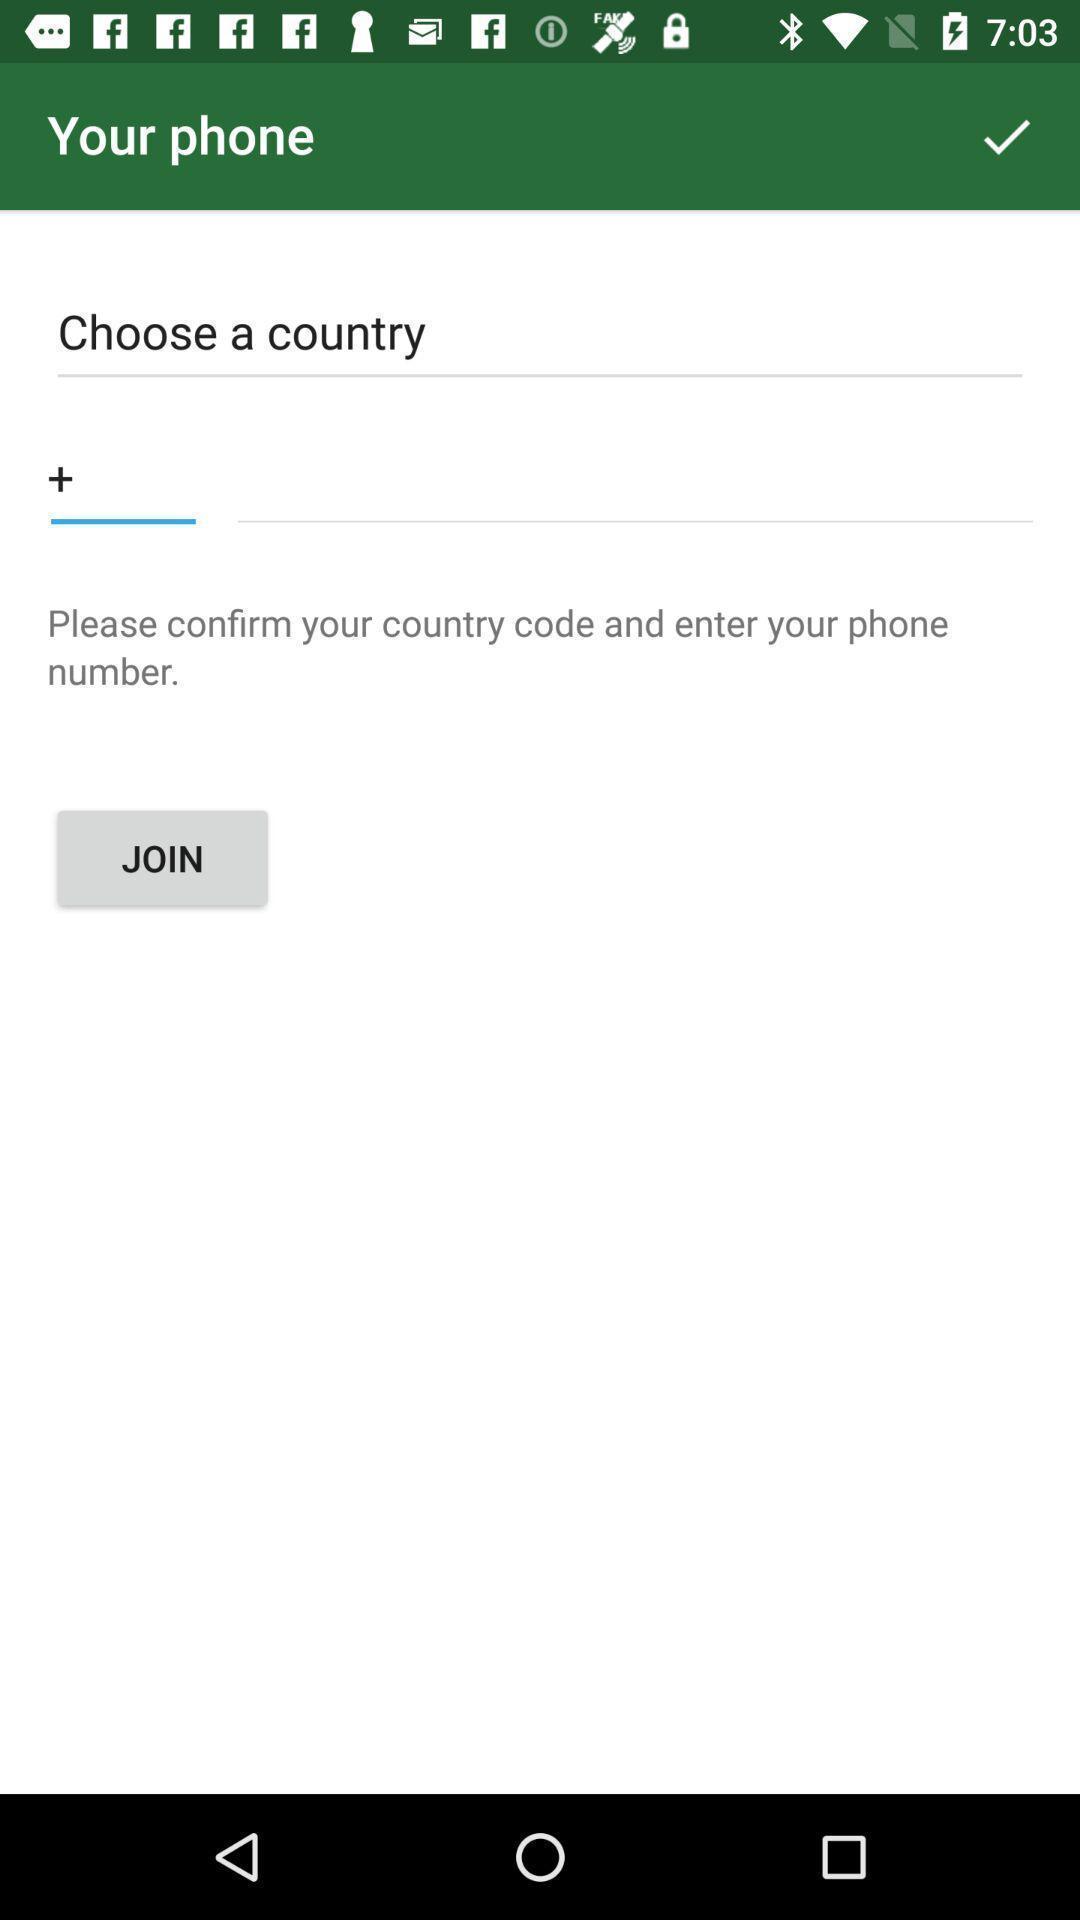Describe the key features of this screenshot. Page showing multiple fields to enter country and mobile number. 